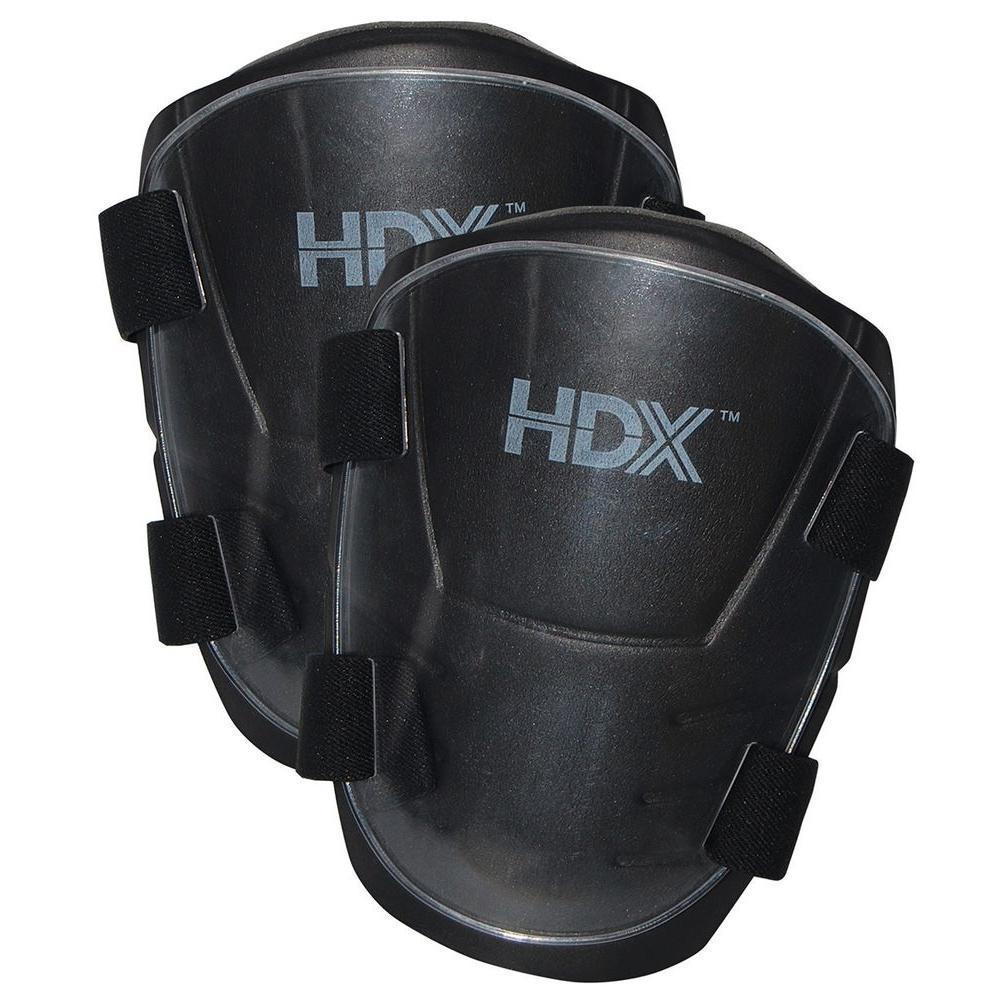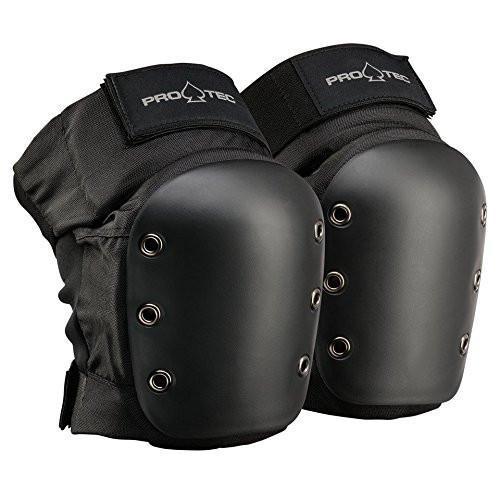The first image is the image on the left, the second image is the image on the right. For the images shown, is this caption "Exactly two pairs of knee pads are shown, each solid black with logos, one pair viewed from the front and one at an angle to give a side view." true? Answer yes or no. Yes. The first image is the image on the left, the second image is the image on the right. Assess this claim about the two images: "At least one kneepad appears to be worn on a leg, and all kneepads are facing rightwards.". Correct or not? Answer yes or no. No. 